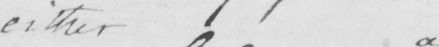What does this handwritten line say? either a 